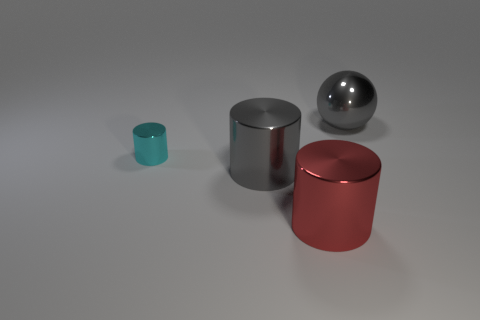Subtract all big metallic cylinders. How many cylinders are left? 1 Add 2 gray metallic spheres. How many objects exist? 6 Subtract all red cylinders. How many cylinders are left? 2 Subtract all cylinders. How many objects are left? 1 Subtract all large metallic objects. Subtract all red things. How many objects are left? 0 Add 3 large gray shiny things. How many large gray shiny things are left? 5 Add 1 large brown objects. How many large brown objects exist? 1 Subtract 1 red cylinders. How many objects are left? 3 Subtract all yellow balls. Subtract all cyan cubes. How many balls are left? 1 